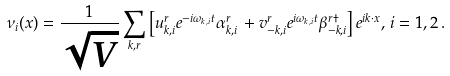Convert formula to latex. <formula><loc_0><loc_0><loc_500><loc_500>\nu _ { i } ( x ) = \frac { 1 } { \sqrt { V } } \sum _ { { k } , r } \left [ u _ { { k } , i } ^ { r } e ^ { - i \omega _ { k , i } t } \alpha _ { { k } , i } ^ { r } \, + v _ { - { k } , i } ^ { r } e ^ { i \omega _ { k , i } t } \beta _ { - { k } , i } ^ { r \dag } \right ] e ^ { i { k } \cdot { x } } , \, i = 1 , 2 \, .</formula> 